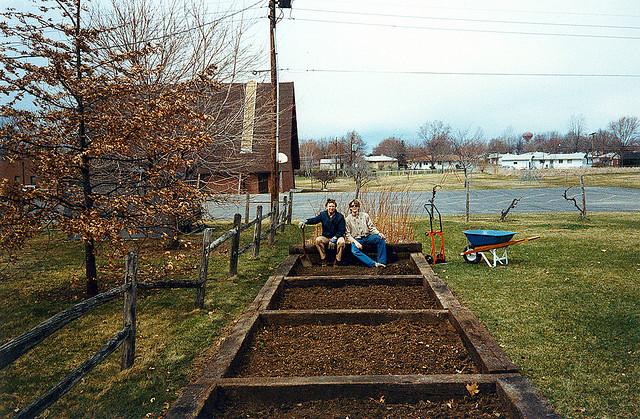Is this an idyllic summer scene?
Write a very short answer. No. Are the planting their garden?
Write a very short answer. Yes. How many people do you see?
Be succinct. 2. 